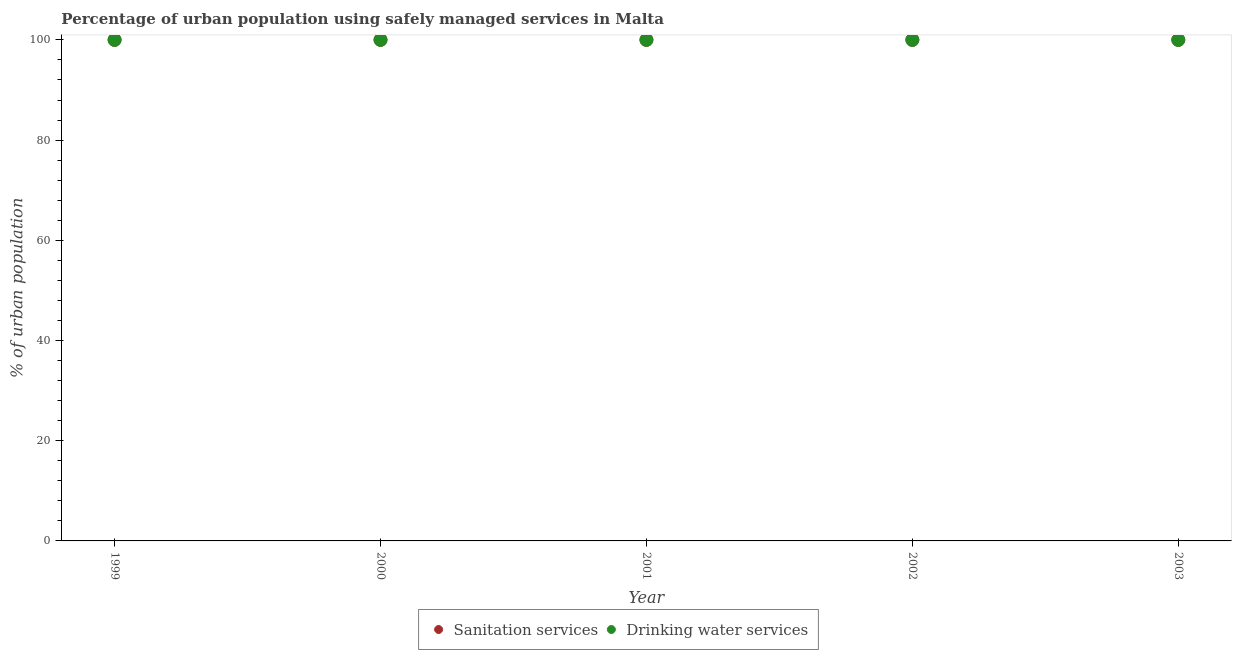How many different coloured dotlines are there?
Offer a terse response. 2. Is the number of dotlines equal to the number of legend labels?
Your response must be concise. Yes. What is the percentage of urban population who used drinking water services in 1999?
Your answer should be compact. 100. Across all years, what is the maximum percentage of urban population who used sanitation services?
Provide a short and direct response. 100. Across all years, what is the minimum percentage of urban population who used sanitation services?
Offer a very short reply. 100. In which year was the percentage of urban population who used sanitation services maximum?
Your answer should be very brief. 1999. What is the total percentage of urban population who used drinking water services in the graph?
Your response must be concise. 500. What is the difference between the percentage of urban population who used sanitation services in 1999 and the percentage of urban population who used drinking water services in 2002?
Make the answer very short. 0. What is the average percentage of urban population who used sanitation services per year?
Your answer should be very brief. 100. In the year 1999, what is the difference between the percentage of urban population who used sanitation services and percentage of urban population who used drinking water services?
Your response must be concise. 0. In how many years, is the percentage of urban population who used drinking water services greater than 40 %?
Ensure brevity in your answer.  5. Is the percentage of urban population who used sanitation services in 1999 less than that in 2000?
Give a very brief answer. No. What is the difference between the highest and the lowest percentage of urban population who used sanitation services?
Give a very brief answer. 0. In how many years, is the percentage of urban population who used sanitation services greater than the average percentage of urban population who used sanitation services taken over all years?
Provide a succinct answer. 0. Is the sum of the percentage of urban population who used drinking water services in 1999 and 2002 greater than the maximum percentage of urban population who used sanitation services across all years?
Offer a very short reply. Yes. Does the percentage of urban population who used drinking water services monotonically increase over the years?
Ensure brevity in your answer.  No. Is the percentage of urban population who used sanitation services strictly greater than the percentage of urban population who used drinking water services over the years?
Provide a short and direct response. No. Is the percentage of urban population who used drinking water services strictly less than the percentage of urban population who used sanitation services over the years?
Give a very brief answer. No. How many years are there in the graph?
Offer a terse response. 5. What is the difference between two consecutive major ticks on the Y-axis?
Keep it short and to the point. 20. Are the values on the major ticks of Y-axis written in scientific E-notation?
Provide a short and direct response. No. Does the graph contain any zero values?
Offer a very short reply. No. Does the graph contain grids?
Ensure brevity in your answer.  No. How are the legend labels stacked?
Your answer should be very brief. Horizontal. What is the title of the graph?
Keep it short and to the point. Percentage of urban population using safely managed services in Malta. Does "Revenue" appear as one of the legend labels in the graph?
Ensure brevity in your answer.  No. What is the label or title of the Y-axis?
Provide a succinct answer. % of urban population. What is the % of urban population in Sanitation services in 1999?
Provide a succinct answer. 100. What is the % of urban population in Drinking water services in 1999?
Provide a succinct answer. 100. What is the % of urban population in Sanitation services in 2000?
Provide a succinct answer. 100. What is the % of urban population in Drinking water services in 2000?
Your answer should be very brief. 100. What is the % of urban population in Sanitation services in 2001?
Keep it short and to the point. 100. What is the % of urban population in Drinking water services in 2001?
Your response must be concise. 100. What is the % of urban population of Drinking water services in 2003?
Provide a short and direct response. 100. Across all years, what is the maximum % of urban population in Sanitation services?
Your answer should be very brief. 100. Across all years, what is the minimum % of urban population in Sanitation services?
Keep it short and to the point. 100. What is the total % of urban population of Sanitation services in the graph?
Make the answer very short. 500. What is the total % of urban population in Drinking water services in the graph?
Give a very brief answer. 500. What is the difference between the % of urban population in Sanitation services in 1999 and that in 2002?
Your answer should be compact. 0. What is the difference between the % of urban population of Sanitation services in 1999 and that in 2003?
Provide a short and direct response. 0. What is the difference between the % of urban population in Drinking water services in 2000 and that in 2003?
Keep it short and to the point. 0. What is the difference between the % of urban population of Drinking water services in 2001 and that in 2003?
Your response must be concise. 0. What is the difference between the % of urban population of Sanitation services in 2002 and that in 2003?
Offer a very short reply. 0. What is the difference between the % of urban population of Drinking water services in 2002 and that in 2003?
Give a very brief answer. 0. What is the difference between the % of urban population in Sanitation services in 1999 and the % of urban population in Drinking water services in 2000?
Your response must be concise. 0. What is the difference between the % of urban population of Sanitation services in 1999 and the % of urban population of Drinking water services in 2001?
Offer a very short reply. 0. What is the difference between the % of urban population in Sanitation services in 2000 and the % of urban population in Drinking water services in 2002?
Keep it short and to the point. 0. What is the difference between the % of urban population in Sanitation services in 2001 and the % of urban population in Drinking water services in 2003?
Ensure brevity in your answer.  0. What is the difference between the % of urban population of Sanitation services in 2002 and the % of urban population of Drinking water services in 2003?
Ensure brevity in your answer.  0. What is the average % of urban population of Sanitation services per year?
Keep it short and to the point. 100. In the year 2001, what is the difference between the % of urban population in Sanitation services and % of urban population in Drinking water services?
Offer a terse response. 0. In the year 2002, what is the difference between the % of urban population in Sanitation services and % of urban population in Drinking water services?
Provide a succinct answer. 0. What is the ratio of the % of urban population in Drinking water services in 1999 to that in 2000?
Make the answer very short. 1. What is the ratio of the % of urban population of Sanitation services in 1999 to that in 2002?
Ensure brevity in your answer.  1. What is the ratio of the % of urban population of Sanitation services in 1999 to that in 2003?
Offer a very short reply. 1. What is the ratio of the % of urban population of Sanitation services in 2000 to that in 2001?
Keep it short and to the point. 1. What is the ratio of the % of urban population of Sanitation services in 2000 to that in 2002?
Give a very brief answer. 1. What is the ratio of the % of urban population of Drinking water services in 2000 to that in 2002?
Give a very brief answer. 1. What is the ratio of the % of urban population of Drinking water services in 2000 to that in 2003?
Offer a very short reply. 1. What is the ratio of the % of urban population in Drinking water services in 2001 to that in 2003?
Make the answer very short. 1. What is the ratio of the % of urban population of Sanitation services in 2002 to that in 2003?
Make the answer very short. 1. What is the difference between the highest and the second highest % of urban population in Sanitation services?
Your answer should be compact. 0. What is the difference between the highest and the second highest % of urban population in Drinking water services?
Provide a short and direct response. 0. 